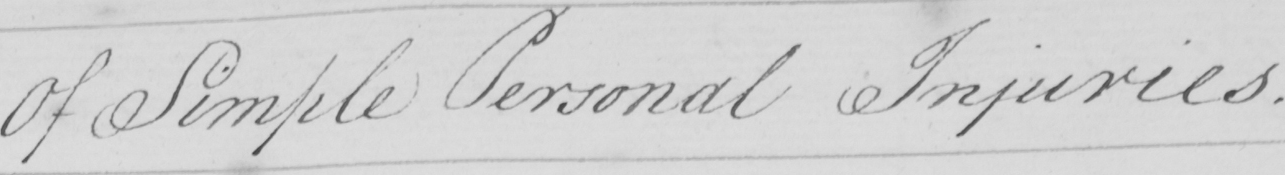Can you tell me what this handwritten text says? Of Simple Personal Injuries . 